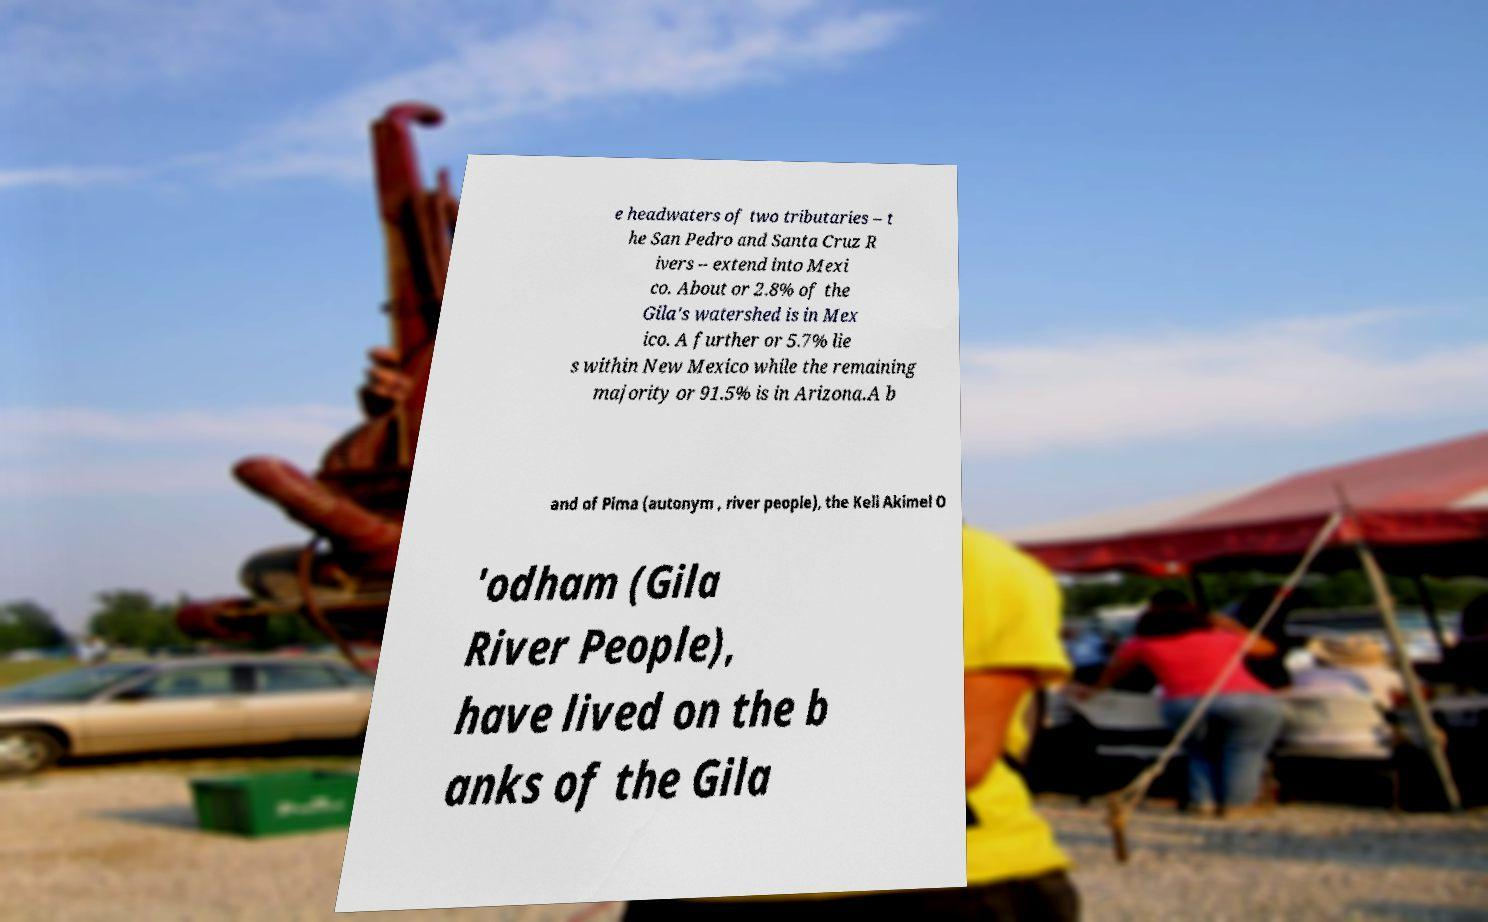Please identify and transcribe the text found in this image. e headwaters of two tributaries – t he San Pedro and Santa Cruz R ivers – extend into Mexi co. About or 2.8% of the Gila's watershed is in Mex ico. A further or 5.7% lie s within New Mexico while the remaining majority or 91.5% is in Arizona.A b and of Pima (autonym , river people), the Keli Akimel O 'odham (Gila River People), have lived on the b anks of the Gila 